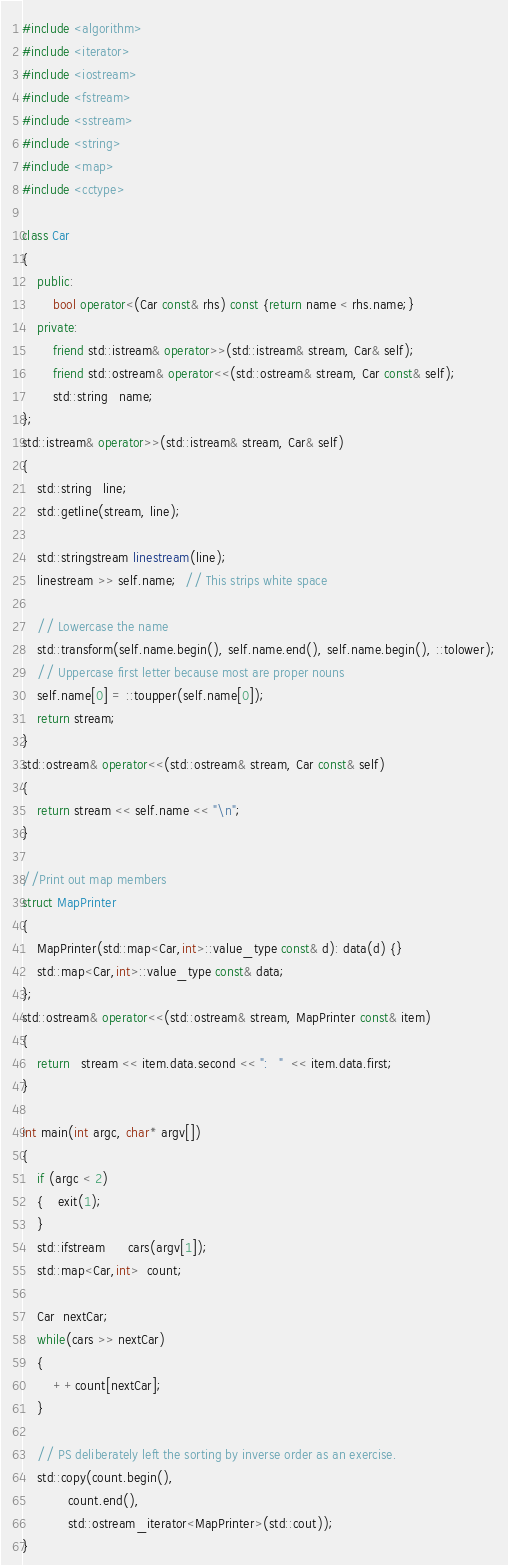<code> <loc_0><loc_0><loc_500><loc_500><_C++_>#include <algorithm>
#include <iterator>
#include <iostream>
#include <fstream>
#include <sstream>
#include <string>
#include <map>
#include <cctype>

class Car
{
	public:
		bool operator<(Car const& rhs) const {return name < rhs.name;}
	private:
		friend std::istream& operator>>(std::istream& stream, Car& self);
		friend std::ostream& operator<<(std::ostream& stream, Car const& self);
		std::string   name;
};
std::istream& operator>>(std::istream& stream, Car& self)
{
	std::string   line;
	std::getline(stream, line);

	std::stringstream linestream(line);
	linestream >> self.name;  // This strips white space

	// Lowercase the name
	std::transform(self.name.begin(), self.name.end(), self.name.begin(), ::tolower);
	// Uppercase first letter because most are proper nouns
	self.name[0] = ::toupper(self.name[0]);
	return stream;
}
std::ostream& operator<<(std::ostream& stream, Car const& self)
{
	return stream << self.name << "\n";
}

//Print out map members
struct MapPrinter
{
	MapPrinter(std::map<Car,int>::value_type const& d): data(d) {}
	std::map<Car,int>::value_type const& data;
};
std::ostream& operator<<(std::ostream& stream, MapPrinter const& item)
{
	return   stream << item.data.second << ":   "  << item.data.first;
}

int main(int argc, char* argv[])
{
	if (argc < 2)
	{    exit(1);
	}
	std::ifstream      cars(argv[1]);
	std::map<Car,int>  count;

	Car  nextCar;
	while(cars >> nextCar)
	{
		++count[nextCar];
	}

	// PS deliberately left the sorting by inverse order as an exercise.
	std::copy(count.begin(),
			count.end(),
			std::ostream_iterator<MapPrinter>(std::cout));
}
</code> 